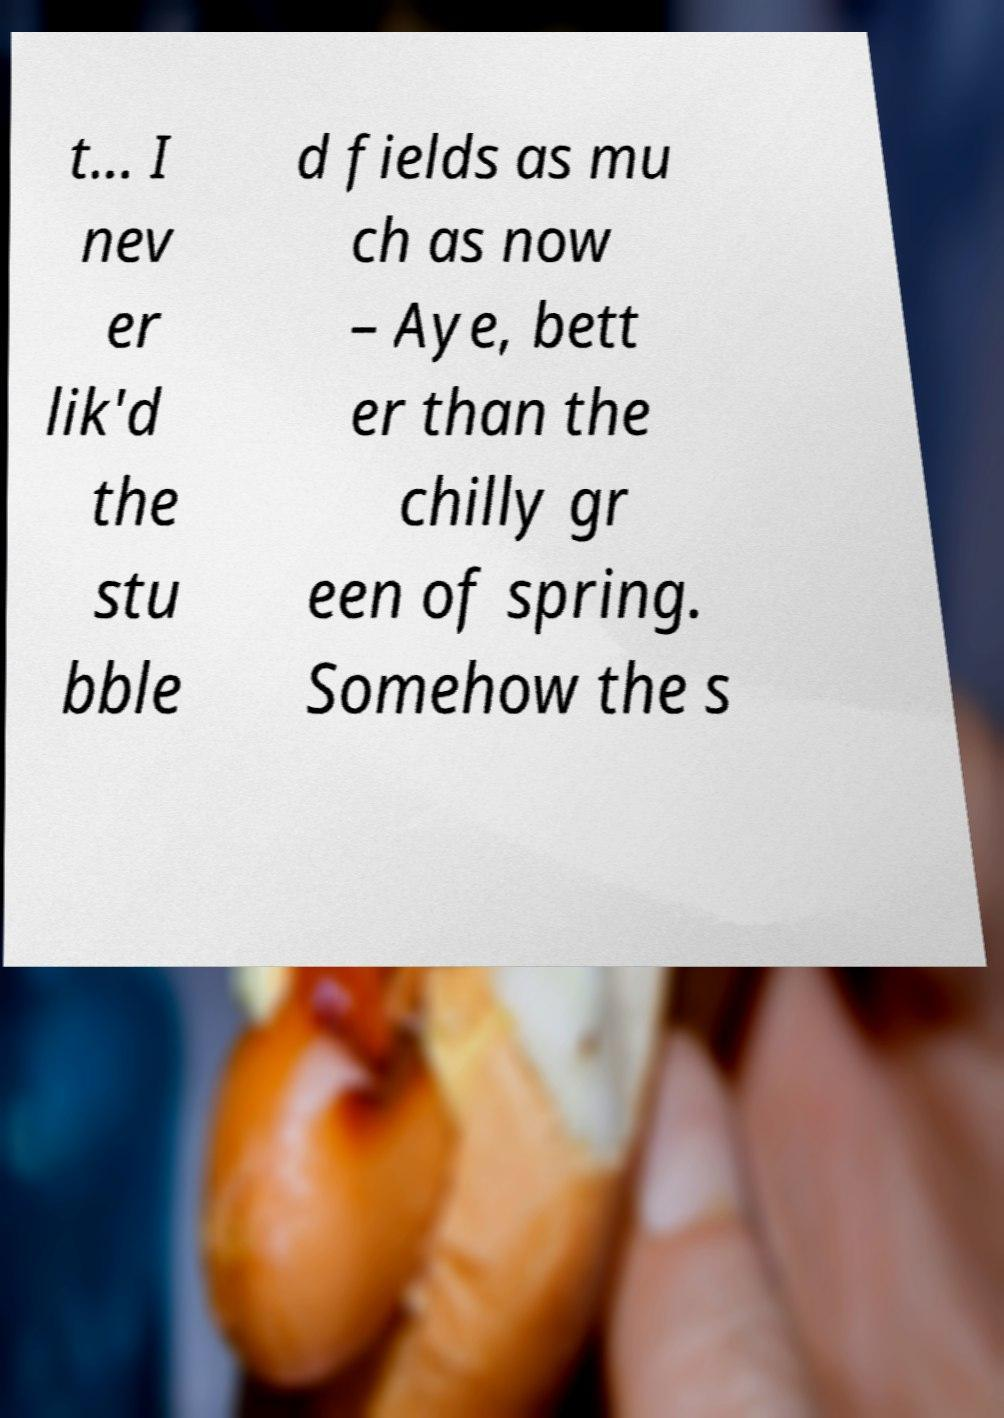Can you read and provide the text displayed in the image?This photo seems to have some interesting text. Can you extract and type it out for me? t... I nev er lik'd the stu bble d fields as mu ch as now – Aye, bett er than the chilly gr een of spring. Somehow the s 